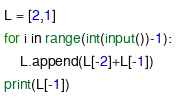Convert code to text. <code><loc_0><loc_0><loc_500><loc_500><_Python_>L = [2,1]
for i in range(int(input())-1):
    L.append(L[-2]+L[-1])
print(L[-1])</code> 